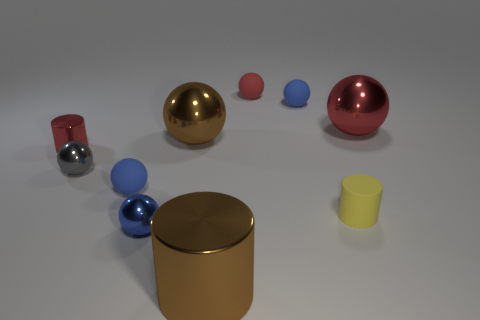What do the different finishes on the objects suggest about the materials they represent? The varied finishes of the objects suggest a range of materials. For example, the metallic sheen of the golden and red spheres indicates a reflective material like metal, while the matte finish of the small red object hints at a non-reflective surface like plastic or rubber.  Can you infer the scale of the objects based on this image? Without a reference object of a known size, it's difficult to determine the exact scale, but the relative sizes and the shadows suggest a mix of small to medium-sized objects one might be able to hold in hand. 